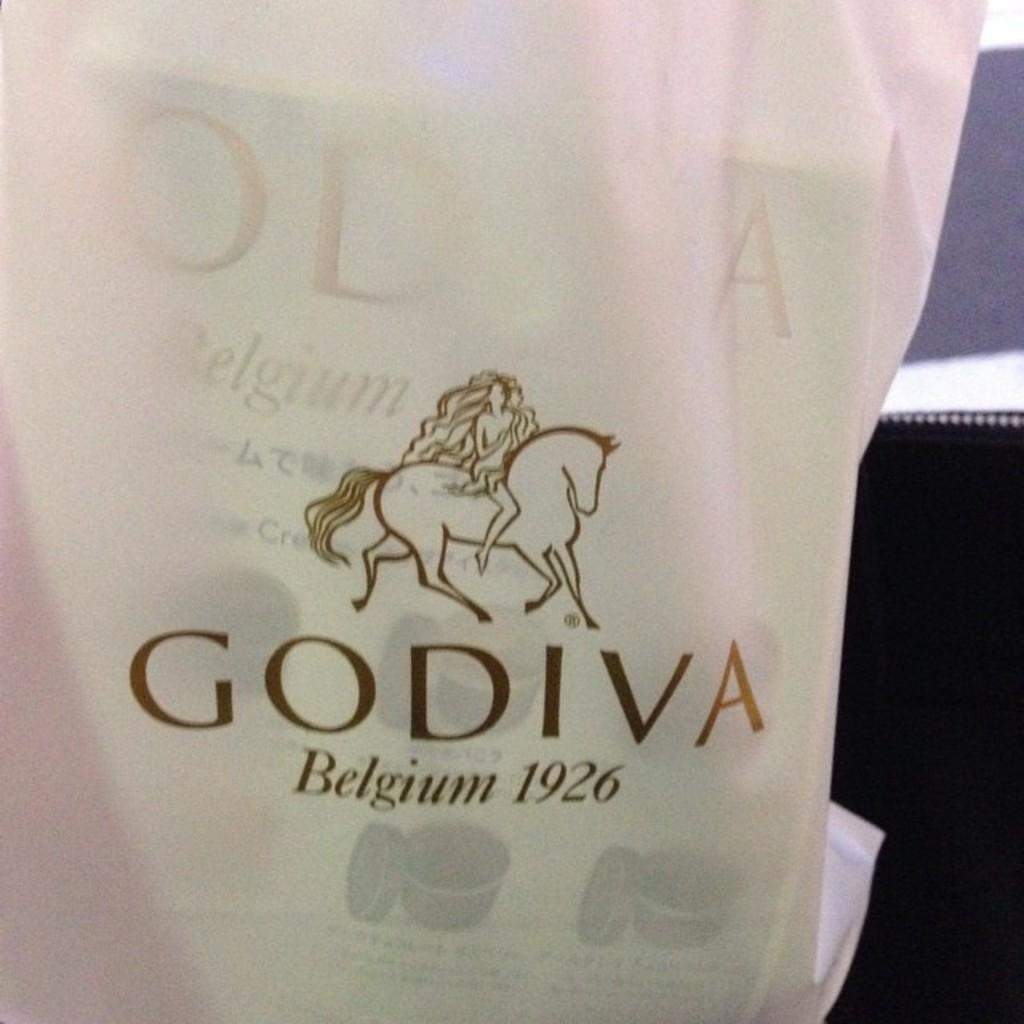<image>
Write a terse but informative summary of the picture. A bag featuring a woman riding a horse with the brand godiva on it. 